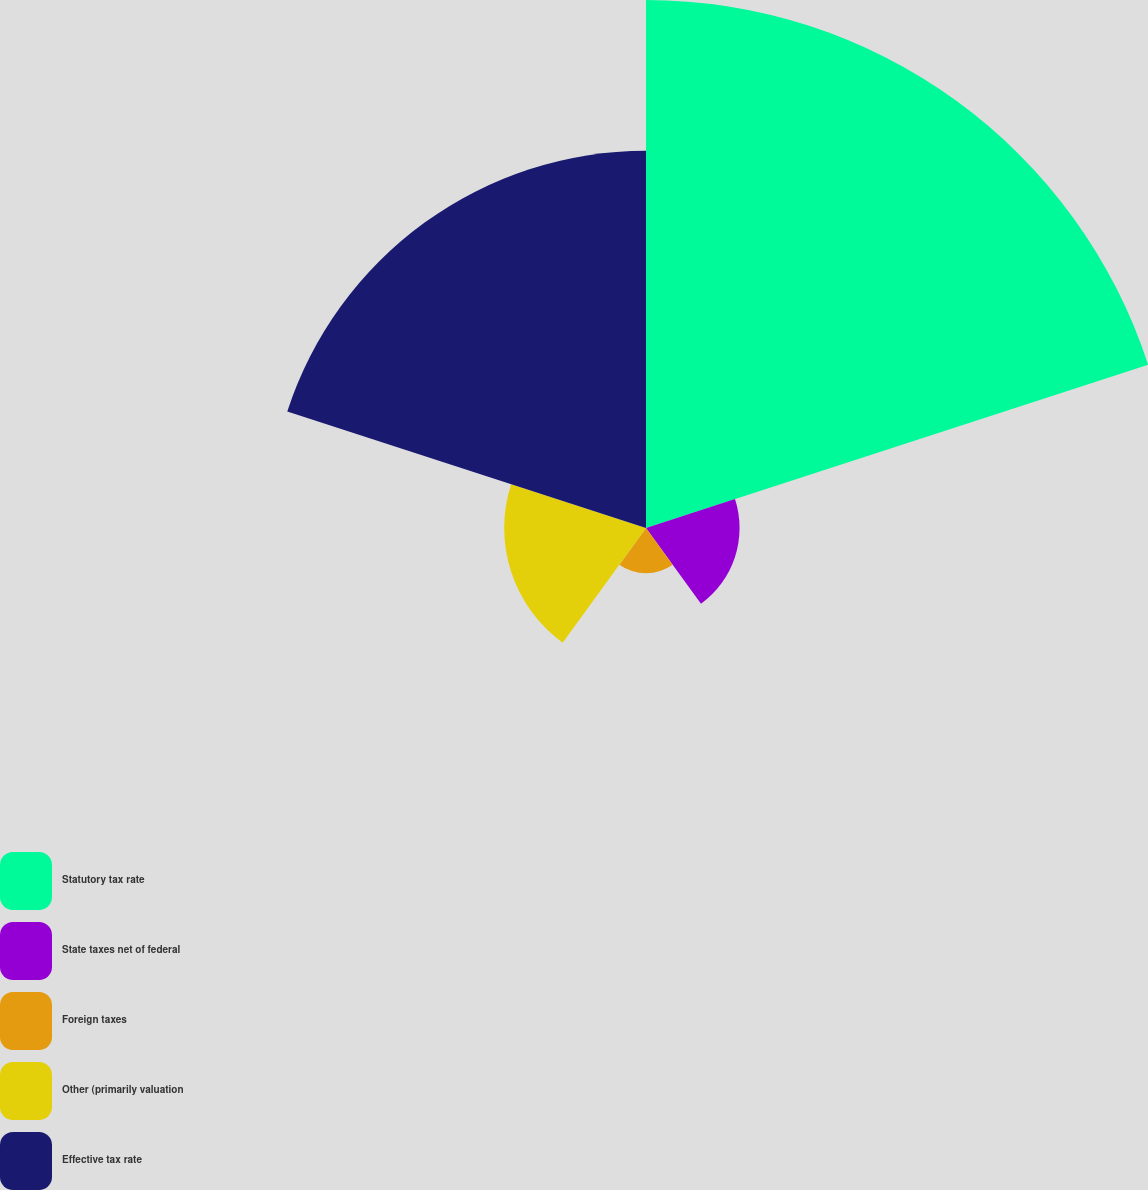Convert chart to OTSL. <chart><loc_0><loc_0><loc_500><loc_500><pie_chart><fcel>Statutory tax rate<fcel>State taxes net of federal<fcel>Foreign taxes<fcel>Other (primarily valuation<fcel>Effective tax rate<nl><fcel>44.53%<fcel>7.89%<fcel>3.82%<fcel>11.96%<fcel>31.81%<nl></chart> 